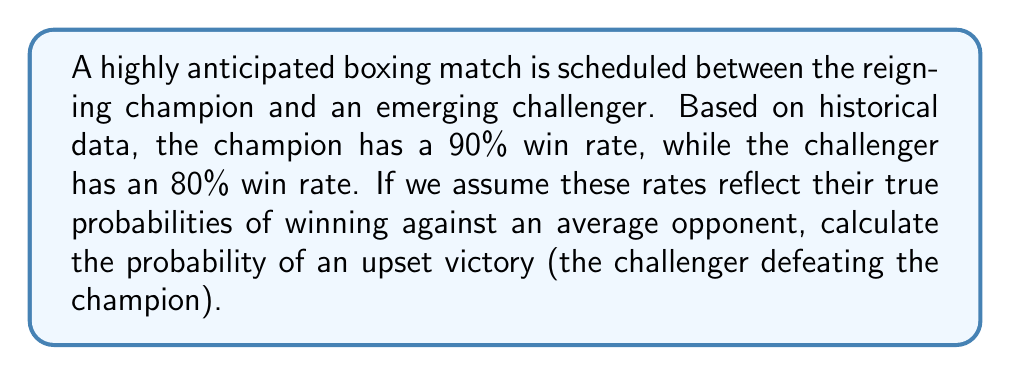Show me your answer to this math problem. To solve this problem, we'll use Bayes' theorem to calculate the probability of the challenger winning against the champion. Let's break it down step-by-step:

1) Let A be the event that the challenger wins, and B be the event that the champion loses.

2) We're given:
   P(not B) = 0.90 (champion's win rate)
   P(A) = 0.80 (challenger's win rate against average opponents)

3) We need to find P(A|B), the probability of the challenger winning given that the champion loses.

4) Bayes' theorem states:

   $$P(A|B) = \frac{P(B|A) \cdot P(A)}{P(B)}$$

5) We know P(A) = 0.80, but we need to calculate P(B) and P(B|A).

6) P(B) is the probability of the champion losing:
   P(B) = 1 - P(not B) = 1 - 0.90 = 0.10

7) P(B|A) is the probability of the champion losing given that the challenger wins. We can assume this is 1, as if the challenger wins, the champion must lose.

8) Now we can plug these values into Bayes' theorem:

   $$P(A|B) = \frac{1 \cdot 0.80}{0.10} = 8$$

9) However, probabilities cannot exceed 1, so we need to interpret this result carefully. It suggests that given the champion loses, the challenger is certain to win.

10) Therefore, the probability of an upset victory is equal to the probability of the champion losing, which is 0.10 or 10%.
Answer: 0.10 